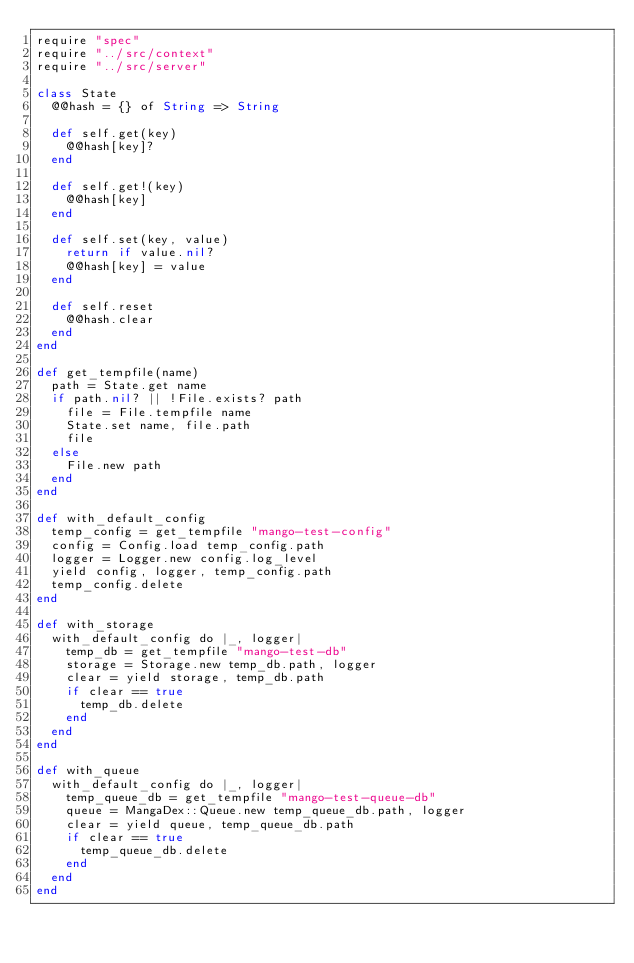Convert code to text. <code><loc_0><loc_0><loc_500><loc_500><_Crystal_>require "spec"
require "../src/context"
require "../src/server"

class State
  @@hash = {} of String => String

  def self.get(key)
    @@hash[key]?
  end

  def self.get!(key)
    @@hash[key]
  end

  def self.set(key, value)
    return if value.nil?
    @@hash[key] = value
  end

  def self.reset
    @@hash.clear
  end
end

def get_tempfile(name)
  path = State.get name
  if path.nil? || !File.exists? path
    file = File.tempfile name
    State.set name, file.path
    file
  else
    File.new path
  end
end

def with_default_config
  temp_config = get_tempfile "mango-test-config"
  config = Config.load temp_config.path
  logger = Logger.new config.log_level
  yield config, logger, temp_config.path
  temp_config.delete
end

def with_storage
  with_default_config do |_, logger|
    temp_db = get_tempfile "mango-test-db"
    storage = Storage.new temp_db.path, logger
    clear = yield storage, temp_db.path
    if clear == true
      temp_db.delete
    end
  end
end

def with_queue
  with_default_config do |_, logger|
    temp_queue_db = get_tempfile "mango-test-queue-db"
    queue = MangaDex::Queue.new temp_queue_db.path, logger
    clear = yield queue, temp_queue_db.path
    if clear == true
      temp_queue_db.delete
    end
  end
end
</code> 